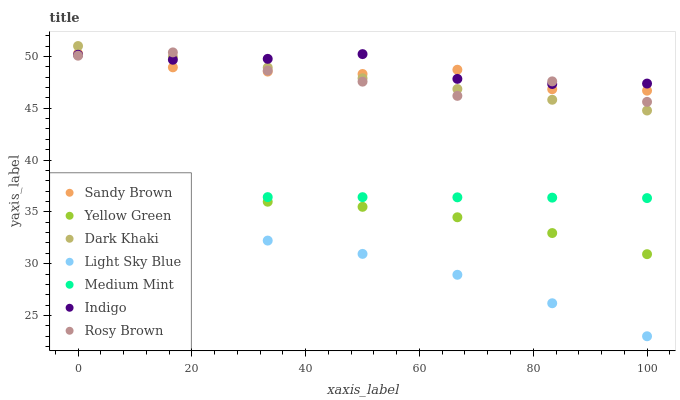Does Light Sky Blue have the minimum area under the curve?
Answer yes or no. Yes. Does Indigo have the maximum area under the curve?
Answer yes or no. Yes. Does Yellow Green have the minimum area under the curve?
Answer yes or no. No. Does Yellow Green have the maximum area under the curve?
Answer yes or no. No. Is Dark Khaki the smoothest?
Answer yes or no. Yes. Is Rosy Brown the roughest?
Answer yes or no. Yes. Is Indigo the smoothest?
Answer yes or no. No. Is Indigo the roughest?
Answer yes or no. No. Does Light Sky Blue have the lowest value?
Answer yes or no. Yes. Does Yellow Green have the lowest value?
Answer yes or no. No. Does Dark Khaki have the highest value?
Answer yes or no. Yes. Does Indigo have the highest value?
Answer yes or no. No. Is Yellow Green less than Rosy Brown?
Answer yes or no. Yes. Is Sandy Brown greater than Medium Mint?
Answer yes or no. Yes. Does Dark Khaki intersect Indigo?
Answer yes or no. Yes. Is Dark Khaki less than Indigo?
Answer yes or no. No. Is Dark Khaki greater than Indigo?
Answer yes or no. No. Does Yellow Green intersect Rosy Brown?
Answer yes or no. No. 